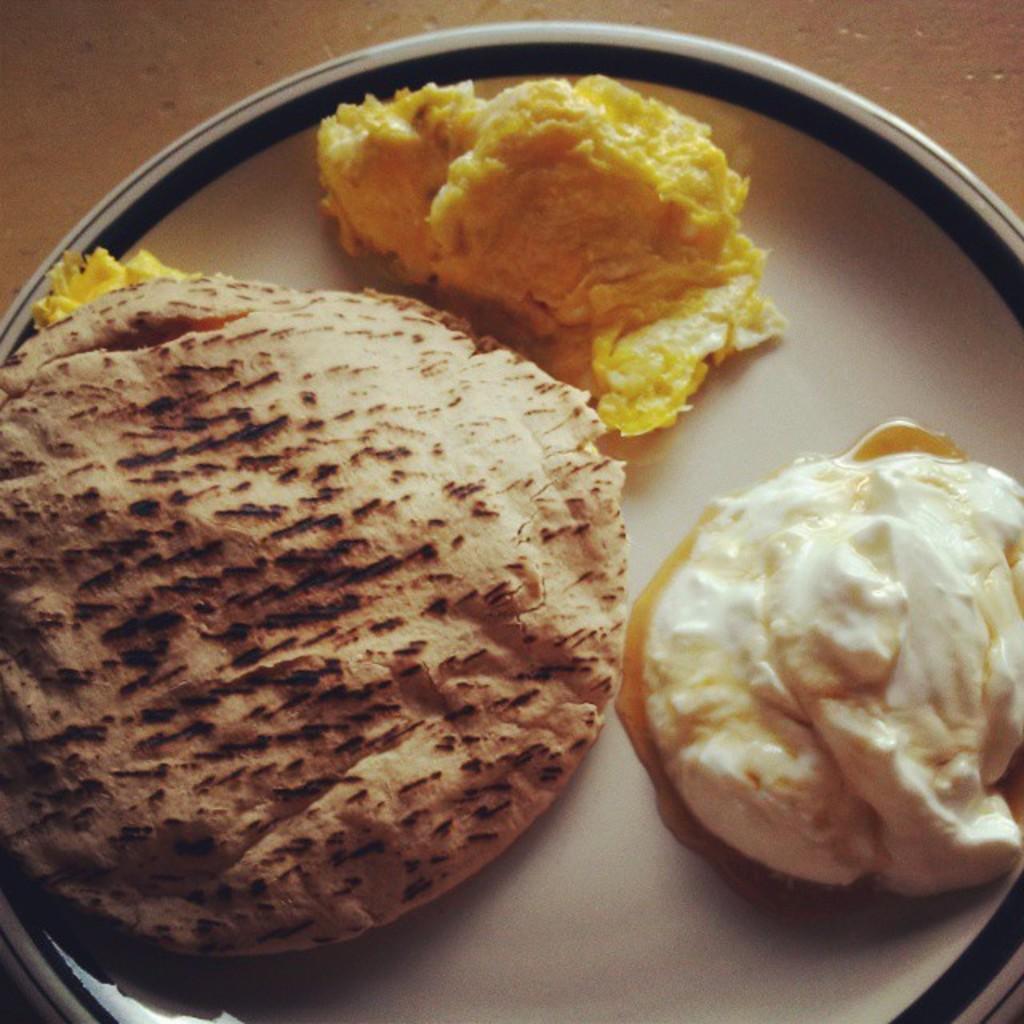Can you describe this image briefly? This image consists of food kept in a plate. At the bottom, there is a floor. 